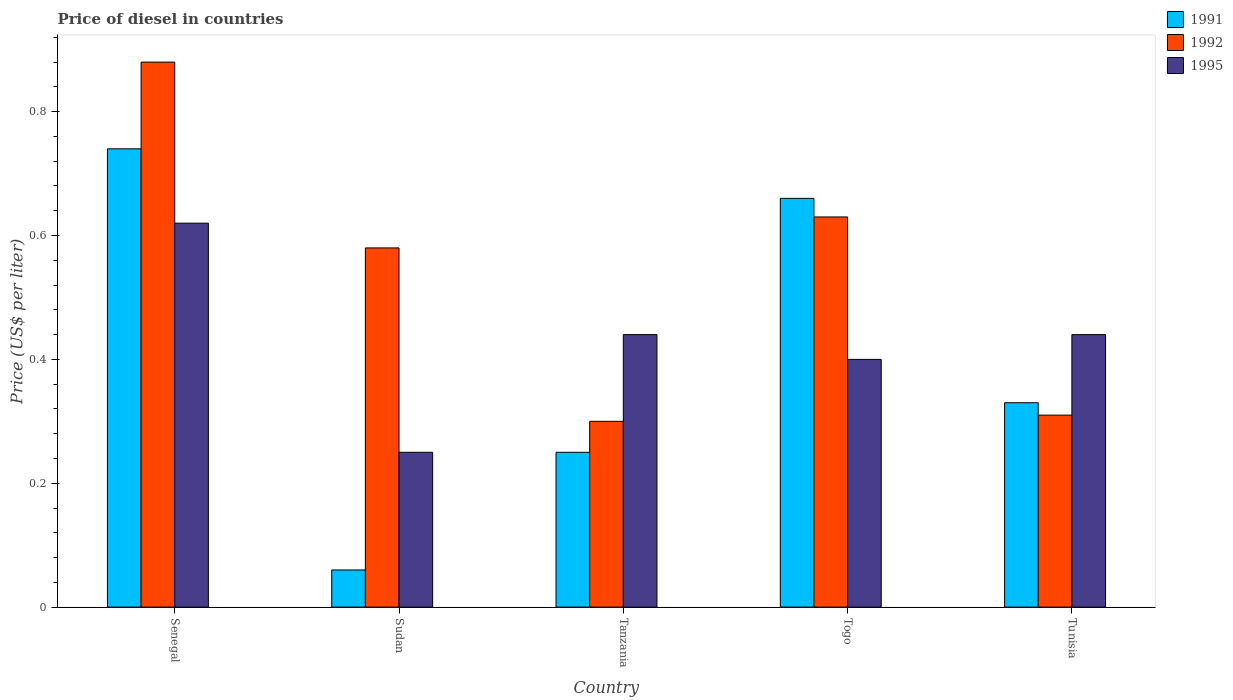How many different coloured bars are there?
Make the answer very short. 3. How many groups of bars are there?
Your response must be concise. 5. Are the number of bars per tick equal to the number of legend labels?
Ensure brevity in your answer.  Yes. How many bars are there on the 5th tick from the right?
Ensure brevity in your answer.  3. What is the label of the 4th group of bars from the left?
Give a very brief answer. Togo. In how many cases, is the number of bars for a given country not equal to the number of legend labels?
Make the answer very short. 0. What is the price of diesel in 1995 in Togo?
Your answer should be very brief. 0.4. Across all countries, what is the maximum price of diesel in 1991?
Offer a terse response. 0.74. In which country was the price of diesel in 1992 maximum?
Ensure brevity in your answer.  Senegal. In which country was the price of diesel in 1995 minimum?
Provide a succinct answer. Sudan. What is the total price of diesel in 1991 in the graph?
Offer a terse response. 2.04. What is the difference between the price of diesel in 1991 in Senegal and that in Togo?
Keep it short and to the point. 0.08. What is the average price of diesel in 1992 per country?
Ensure brevity in your answer.  0.54. What is the difference between the price of diesel of/in 1992 and price of diesel of/in 1991 in Tanzania?
Ensure brevity in your answer.  0.05. In how many countries, is the price of diesel in 1992 greater than 0.16 US$?
Provide a succinct answer. 5. What is the ratio of the price of diesel in 1995 in Senegal to that in Sudan?
Provide a short and direct response. 2.48. What is the difference between the highest and the lowest price of diesel in 1995?
Your answer should be compact. 0.37. Is the sum of the price of diesel in 1992 in Sudan and Tanzania greater than the maximum price of diesel in 1995 across all countries?
Your answer should be very brief. Yes. What does the 3rd bar from the right in Senegal represents?
Ensure brevity in your answer.  1991. What is the difference between two consecutive major ticks on the Y-axis?
Your answer should be compact. 0.2. Are the values on the major ticks of Y-axis written in scientific E-notation?
Give a very brief answer. No. Where does the legend appear in the graph?
Your answer should be compact. Top right. How are the legend labels stacked?
Give a very brief answer. Vertical. What is the title of the graph?
Ensure brevity in your answer.  Price of diesel in countries. What is the label or title of the Y-axis?
Make the answer very short. Price (US$ per liter). What is the Price (US$ per liter) of 1991 in Senegal?
Offer a very short reply. 0.74. What is the Price (US$ per liter) of 1992 in Senegal?
Provide a short and direct response. 0.88. What is the Price (US$ per liter) in 1995 in Senegal?
Offer a very short reply. 0.62. What is the Price (US$ per liter) in 1991 in Sudan?
Your response must be concise. 0.06. What is the Price (US$ per liter) in 1992 in Sudan?
Provide a succinct answer. 0.58. What is the Price (US$ per liter) of 1995 in Sudan?
Offer a terse response. 0.25. What is the Price (US$ per liter) of 1992 in Tanzania?
Your answer should be very brief. 0.3. What is the Price (US$ per liter) of 1995 in Tanzania?
Keep it short and to the point. 0.44. What is the Price (US$ per liter) of 1991 in Togo?
Keep it short and to the point. 0.66. What is the Price (US$ per liter) of 1992 in Togo?
Keep it short and to the point. 0.63. What is the Price (US$ per liter) of 1995 in Togo?
Provide a short and direct response. 0.4. What is the Price (US$ per liter) of 1991 in Tunisia?
Your response must be concise. 0.33. What is the Price (US$ per liter) of 1992 in Tunisia?
Give a very brief answer. 0.31. What is the Price (US$ per liter) in 1995 in Tunisia?
Your answer should be compact. 0.44. Across all countries, what is the maximum Price (US$ per liter) of 1991?
Keep it short and to the point. 0.74. Across all countries, what is the maximum Price (US$ per liter) of 1992?
Offer a terse response. 0.88. Across all countries, what is the maximum Price (US$ per liter) in 1995?
Keep it short and to the point. 0.62. Across all countries, what is the minimum Price (US$ per liter) in 1991?
Your answer should be compact. 0.06. Across all countries, what is the minimum Price (US$ per liter) in 1992?
Offer a terse response. 0.3. Across all countries, what is the minimum Price (US$ per liter) in 1995?
Make the answer very short. 0.25. What is the total Price (US$ per liter) of 1991 in the graph?
Ensure brevity in your answer.  2.04. What is the total Price (US$ per liter) of 1992 in the graph?
Offer a terse response. 2.7. What is the total Price (US$ per liter) of 1995 in the graph?
Provide a succinct answer. 2.15. What is the difference between the Price (US$ per liter) of 1991 in Senegal and that in Sudan?
Ensure brevity in your answer.  0.68. What is the difference between the Price (US$ per liter) in 1992 in Senegal and that in Sudan?
Provide a short and direct response. 0.3. What is the difference between the Price (US$ per liter) in 1995 in Senegal and that in Sudan?
Your answer should be compact. 0.37. What is the difference between the Price (US$ per liter) in 1991 in Senegal and that in Tanzania?
Offer a very short reply. 0.49. What is the difference between the Price (US$ per liter) in 1992 in Senegal and that in Tanzania?
Your response must be concise. 0.58. What is the difference between the Price (US$ per liter) in 1995 in Senegal and that in Tanzania?
Provide a short and direct response. 0.18. What is the difference between the Price (US$ per liter) in 1992 in Senegal and that in Togo?
Keep it short and to the point. 0.25. What is the difference between the Price (US$ per liter) of 1995 in Senegal and that in Togo?
Offer a terse response. 0.22. What is the difference between the Price (US$ per liter) in 1991 in Senegal and that in Tunisia?
Provide a short and direct response. 0.41. What is the difference between the Price (US$ per liter) in 1992 in Senegal and that in Tunisia?
Make the answer very short. 0.57. What is the difference between the Price (US$ per liter) in 1995 in Senegal and that in Tunisia?
Your response must be concise. 0.18. What is the difference between the Price (US$ per liter) of 1991 in Sudan and that in Tanzania?
Your response must be concise. -0.19. What is the difference between the Price (US$ per liter) in 1992 in Sudan and that in Tanzania?
Offer a terse response. 0.28. What is the difference between the Price (US$ per liter) of 1995 in Sudan and that in Tanzania?
Your answer should be compact. -0.19. What is the difference between the Price (US$ per liter) in 1991 in Sudan and that in Tunisia?
Your answer should be very brief. -0.27. What is the difference between the Price (US$ per liter) of 1992 in Sudan and that in Tunisia?
Ensure brevity in your answer.  0.27. What is the difference between the Price (US$ per liter) of 1995 in Sudan and that in Tunisia?
Your answer should be compact. -0.19. What is the difference between the Price (US$ per liter) in 1991 in Tanzania and that in Togo?
Your response must be concise. -0.41. What is the difference between the Price (US$ per liter) of 1992 in Tanzania and that in Togo?
Your answer should be very brief. -0.33. What is the difference between the Price (US$ per liter) in 1991 in Tanzania and that in Tunisia?
Your answer should be compact. -0.08. What is the difference between the Price (US$ per liter) in 1992 in Tanzania and that in Tunisia?
Your answer should be very brief. -0.01. What is the difference between the Price (US$ per liter) of 1991 in Togo and that in Tunisia?
Offer a terse response. 0.33. What is the difference between the Price (US$ per liter) in 1992 in Togo and that in Tunisia?
Your answer should be very brief. 0.32. What is the difference between the Price (US$ per liter) of 1995 in Togo and that in Tunisia?
Ensure brevity in your answer.  -0.04. What is the difference between the Price (US$ per liter) in 1991 in Senegal and the Price (US$ per liter) in 1992 in Sudan?
Provide a succinct answer. 0.16. What is the difference between the Price (US$ per liter) of 1991 in Senegal and the Price (US$ per liter) of 1995 in Sudan?
Ensure brevity in your answer.  0.49. What is the difference between the Price (US$ per liter) in 1992 in Senegal and the Price (US$ per liter) in 1995 in Sudan?
Make the answer very short. 0.63. What is the difference between the Price (US$ per liter) in 1991 in Senegal and the Price (US$ per liter) in 1992 in Tanzania?
Your answer should be very brief. 0.44. What is the difference between the Price (US$ per liter) of 1991 in Senegal and the Price (US$ per liter) of 1995 in Tanzania?
Offer a very short reply. 0.3. What is the difference between the Price (US$ per liter) of 1992 in Senegal and the Price (US$ per liter) of 1995 in Tanzania?
Your answer should be very brief. 0.44. What is the difference between the Price (US$ per liter) of 1991 in Senegal and the Price (US$ per liter) of 1992 in Togo?
Your answer should be compact. 0.11. What is the difference between the Price (US$ per liter) in 1991 in Senegal and the Price (US$ per liter) in 1995 in Togo?
Your response must be concise. 0.34. What is the difference between the Price (US$ per liter) in 1992 in Senegal and the Price (US$ per liter) in 1995 in Togo?
Make the answer very short. 0.48. What is the difference between the Price (US$ per liter) of 1991 in Senegal and the Price (US$ per liter) of 1992 in Tunisia?
Your response must be concise. 0.43. What is the difference between the Price (US$ per liter) in 1992 in Senegal and the Price (US$ per liter) in 1995 in Tunisia?
Provide a succinct answer. 0.44. What is the difference between the Price (US$ per liter) of 1991 in Sudan and the Price (US$ per liter) of 1992 in Tanzania?
Give a very brief answer. -0.24. What is the difference between the Price (US$ per liter) of 1991 in Sudan and the Price (US$ per liter) of 1995 in Tanzania?
Ensure brevity in your answer.  -0.38. What is the difference between the Price (US$ per liter) in 1992 in Sudan and the Price (US$ per liter) in 1995 in Tanzania?
Provide a succinct answer. 0.14. What is the difference between the Price (US$ per liter) of 1991 in Sudan and the Price (US$ per liter) of 1992 in Togo?
Offer a terse response. -0.57. What is the difference between the Price (US$ per liter) of 1991 in Sudan and the Price (US$ per liter) of 1995 in Togo?
Provide a short and direct response. -0.34. What is the difference between the Price (US$ per liter) of 1992 in Sudan and the Price (US$ per liter) of 1995 in Togo?
Offer a terse response. 0.18. What is the difference between the Price (US$ per liter) in 1991 in Sudan and the Price (US$ per liter) in 1995 in Tunisia?
Give a very brief answer. -0.38. What is the difference between the Price (US$ per liter) in 1992 in Sudan and the Price (US$ per liter) in 1995 in Tunisia?
Provide a succinct answer. 0.14. What is the difference between the Price (US$ per liter) of 1991 in Tanzania and the Price (US$ per liter) of 1992 in Togo?
Offer a very short reply. -0.38. What is the difference between the Price (US$ per liter) of 1991 in Tanzania and the Price (US$ per liter) of 1995 in Togo?
Give a very brief answer. -0.15. What is the difference between the Price (US$ per liter) of 1991 in Tanzania and the Price (US$ per liter) of 1992 in Tunisia?
Give a very brief answer. -0.06. What is the difference between the Price (US$ per liter) in 1991 in Tanzania and the Price (US$ per liter) in 1995 in Tunisia?
Ensure brevity in your answer.  -0.19. What is the difference between the Price (US$ per liter) in 1992 in Tanzania and the Price (US$ per liter) in 1995 in Tunisia?
Offer a terse response. -0.14. What is the difference between the Price (US$ per liter) of 1991 in Togo and the Price (US$ per liter) of 1992 in Tunisia?
Offer a terse response. 0.35. What is the difference between the Price (US$ per liter) in 1991 in Togo and the Price (US$ per liter) in 1995 in Tunisia?
Offer a very short reply. 0.22. What is the difference between the Price (US$ per liter) of 1992 in Togo and the Price (US$ per liter) of 1995 in Tunisia?
Give a very brief answer. 0.19. What is the average Price (US$ per liter) in 1991 per country?
Provide a succinct answer. 0.41. What is the average Price (US$ per liter) of 1992 per country?
Your answer should be very brief. 0.54. What is the average Price (US$ per liter) in 1995 per country?
Your response must be concise. 0.43. What is the difference between the Price (US$ per liter) of 1991 and Price (US$ per liter) of 1992 in Senegal?
Offer a terse response. -0.14. What is the difference between the Price (US$ per liter) in 1991 and Price (US$ per liter) in 1995 in Senegal?
Your response must be concise. 0.12. What is the difference between the Price (US$ per liter) in 1992 and Price (US$ per liter) in 1995 in Senegal?
Offer a terse response. 0.26. What is the difference between the Price (US$ per liter) of 1991 and Price (US$ per liter) of 1992 in Sudan?
Ensure brevity in your answer.  -0.52. What is the difference between the Price (US$ per liter) of 1991 and Price (US$ per liter) of 1995 in Sudan?
Your answer should be compact. -0.19. What is the difference between the Price (US$ per liter) of 1992 and Price (US$ per liter) of 1995 in Sudan?
Give a very brief answer. 0.33. What is the difference between the Price (US$ per liter) of 1991 and Price (US$ per liter) of 1995 in Tanzania?
Your answer should be very brief. -0.19. What is the difference between the Price (US$ per liter) of 1992 and Price (US$ per liter) of 1995 in Tanzania?
Your answer should be very brief. -0.14. What is the difference between the Price (US$ per liter) in 1991 and Price (US$ per liter) in 1995 in Togo?
Give a very brief answer. 0.26. What is the difference between the Price (US$ per liter) in 1992 and Price (US$ per liter) in 1995 in Togo?
Your answer should be very brief. 0.23. What is the difference between the Price (US$ per liter) in 1991 and Price (US$ per liter) in 1992 in Tunisia?
Offer a very short reply. 0.02. What is the difference between the Price (US$ per liter) in 1991 and Price (US$ per liter) in 1995 in Tunisia?
Offer a very short reply. -0.11. What is the difference between the Price (US$ per liter) of 1992 and Price (US$ per liter) of 1995 in Tunisia?
Ensure brevity in your answer.  -0.13. What is the ratio of the Price (US$ per liter) in 1991 in Senegal to that in Sudan?
Your response must be concise. 12.33. What is the ratio of the Price (US$ per liter) of 1992 in Senegal to that in Sudan?
Your response must be concise. 1.52. What is the ratio of the Price (US$ per liter) in 1995 in Senegal to that in Sudan?
Offer a terse response. 2.48. What is the ratio of the Price (US$ per liter) in 1991 in Senegal to that in Tanzania?
Ensure brevity in your answer.  2.96. What is the ratio of the Price (US$ per liter) in 1992 in Senegal to that in Tanzania?
Keep it short and to the point. 2.93. What is the ratio of the Price (US$ per liter) in 1995 in Senegal to that in Tanzania?
Make the answer very short. 1.41. What is the ratio of the Price (US$ per liter) in 1991 in Senegal to that in Togo?
Make the answer very short. 1.12. What is the ratio of the Price (US$ per liter) of 1992 in Senegal to that in Togo?
Make the answer very short. 1.4. What is the ratio of the Price (US$ per liter) in 1995 in Senegal to that in Togo?
Your answer should be very brief. 1.55. What is the ratio of the Price (US$ per liter) in 1991 in Senegal to that in Tunisia?
Offer a terse response. 2.24. What is the ratio of the Price (US$ per liter) in 1992 in Senegal to that in Tunisia?
Give a very brief answer. 2.84. What is the ratio of the Price (US$ per liter) in 1995 in Senegal to that in Tunisia?
Provide a short and direct response. 1.41. What is the ratio of the Price (US$ per liter) of 1991 in Sudan to that in Tanzania?
Keep it short and to the point. 0.24. What is the ratio of the Price (US$ per liter) of 1992 in Sudan to that in Tanzania?
Make the answer very short. 1.93. What is the ratio of the Price (US$ per liter) in 1995 in Sudan to that in Tanzania?
Make the answer very short. 0.57. What is the ratio of the Price (US$ per liter) of 1991 in Sudan to that in Togo?
Ensure brevity in your answer.  0.09. What is the ratio of the Price (US$ per liter) of 1992 in Sudan to that in Togo?
Offer a terse response. 0.92. What is the ratio of the Price (US$ per liter) in 1995 in Sudan to that in Togo?
Give a very brief answer. 0.62. What is the ratio of the Price (US$ per liter) of 1991 in Sudan to that in Tunisia?
Give a very brief answer. 0.18. What is the ratio of the Price (US$ per liter) in 1992 in Sudan to that in Tunisia?
Provide a succinct answer. 1.87. What is the ratio of the Price (US$ per liter) in 1995 in Sudan to that in Tunisia?
Provide a succinct answer. 0.57. What is the ratio of the Price (US$ per liter) in 1991 in Tanzania to that in Togo?
Offer a very short reply. 0.38. What is the ratio of the Price (US$ per liter) of 1992 in Tanzania to that in Togo?
Provide a succinct answer. 0.48. What is the ratio of the Price (US$ per liter) in 1991 in Tanzania to that in Tunisia?
Your response must be concise. 0.76. What is the ratio of the Price (US$ per liter) in 1992 in Tanzania to that in Tunisia?
Ensure brevity in your answer.  0.97. What is the ratio of the Price (US$ per liter) of 1992 in Togo to that in Tunisia?
Make the answer very short. 2.03. What is the difference between the highest and the second highest Price (US$ per liter) of 1995?
Offer a very short reply. 0.18. What is the difference between the highest and the lowest Price (US$ per liter) in 1991?
Provide a succinct answer. 0.68. What is the difference between the highest and the lowest Price (US$ per liter) of 1992?
Ensure brevity in your answer.  0.58. What is the difference between the highest and the lowest Price (US$ per liter) of 1995?
Provide a succinct answer. 0.37. 